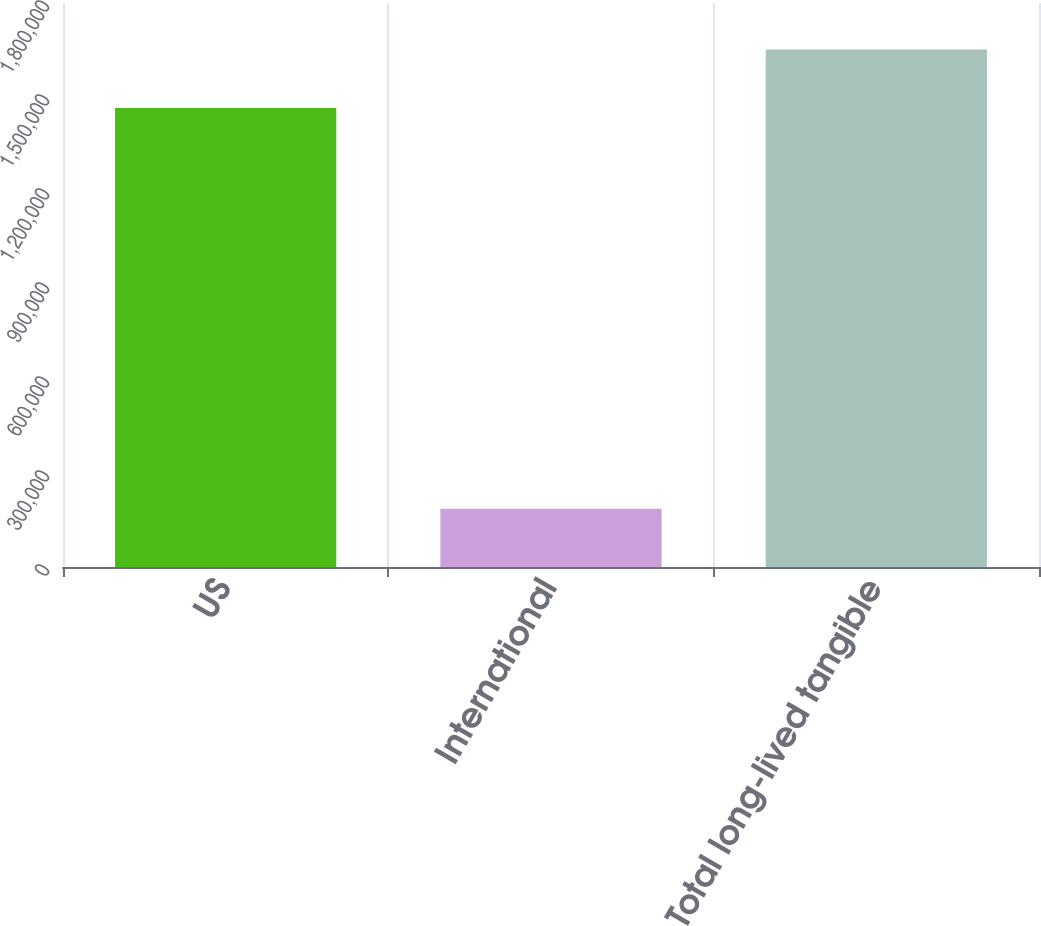<chart> <loc_0><loc_0><loc_500><loc_500><bar_chart><fcel>US<fcel>International<fcel>Total long-lived tangible<nl><fcel>1.46523e+06<fcel>186251<fcel>1.65148e+06<nl></chart> 